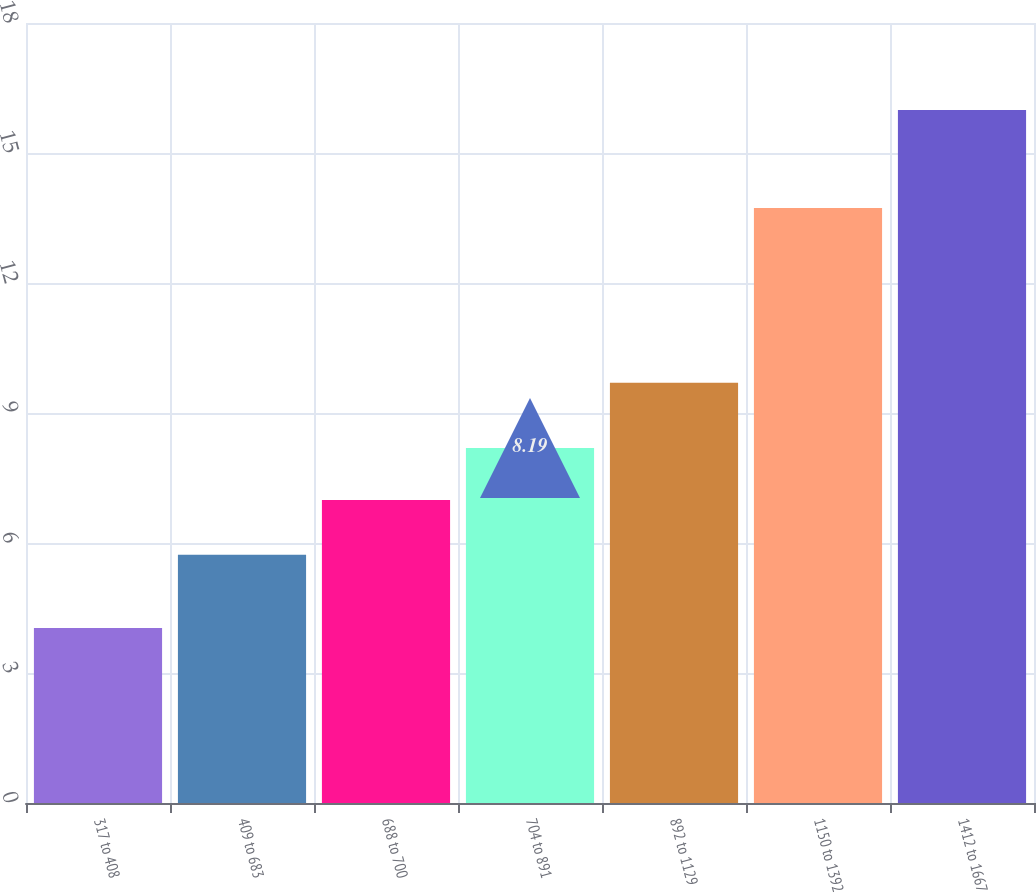<chart> <loc_0><loc_0><loc_500><loc_500><bar_chart><fcel>317 to 408<fcel>409 to 683<fcel>688 to 700<fcel>704 to 891<fcel>892 to 1129<fcel>1150 to 1392<fcel>1412 to 1667<nl><fcel>4.04<fcel>5.73<fcel>6.99<fcel>8.19<fcel>9.7<fcel>13.73<fcel>15.99<nl></chart> 